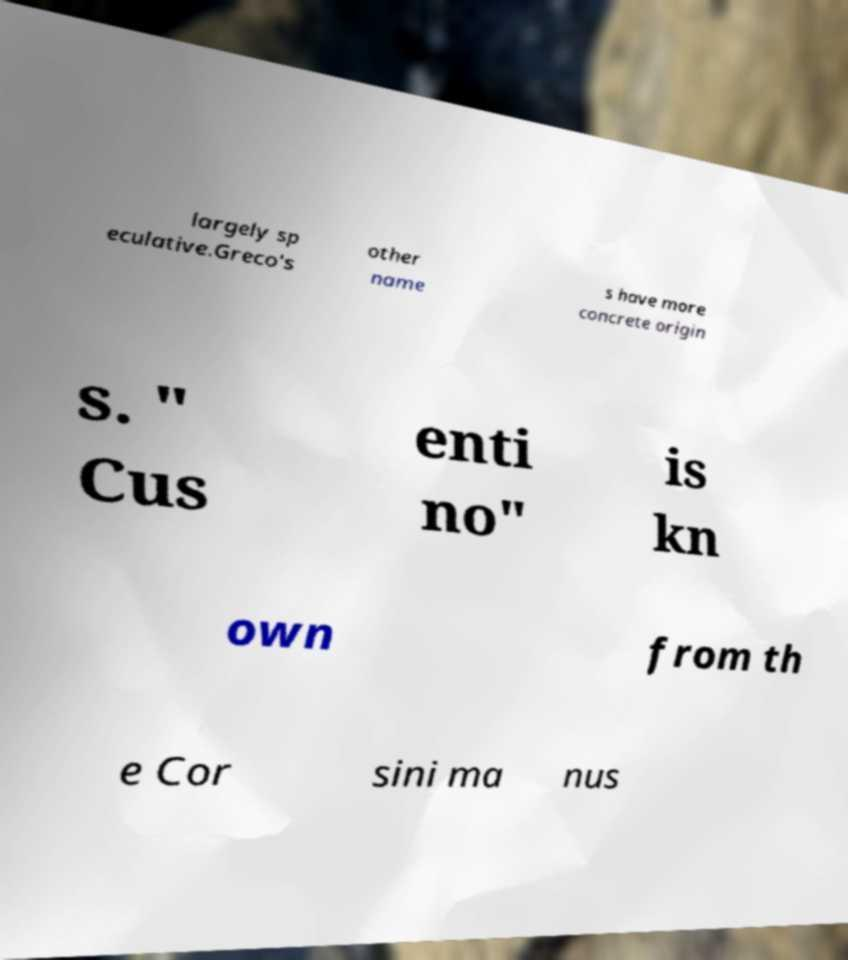Please identify and transcribe the text found in this image. largely sp eculative.Greco's other name s have more concrete origin s. " Cus enti no" is kn own from th e Cor sini ma nus 